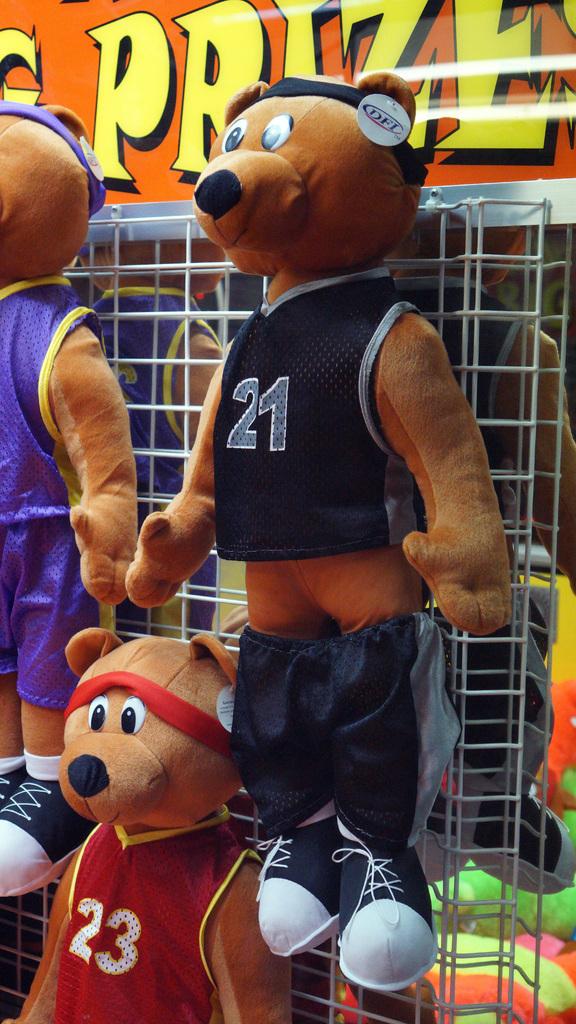Are these stuff animals used as a prize?
Ensure brevity in your answer.  Yes. What number is on the red jersey?
Your response must be concise. 23. 